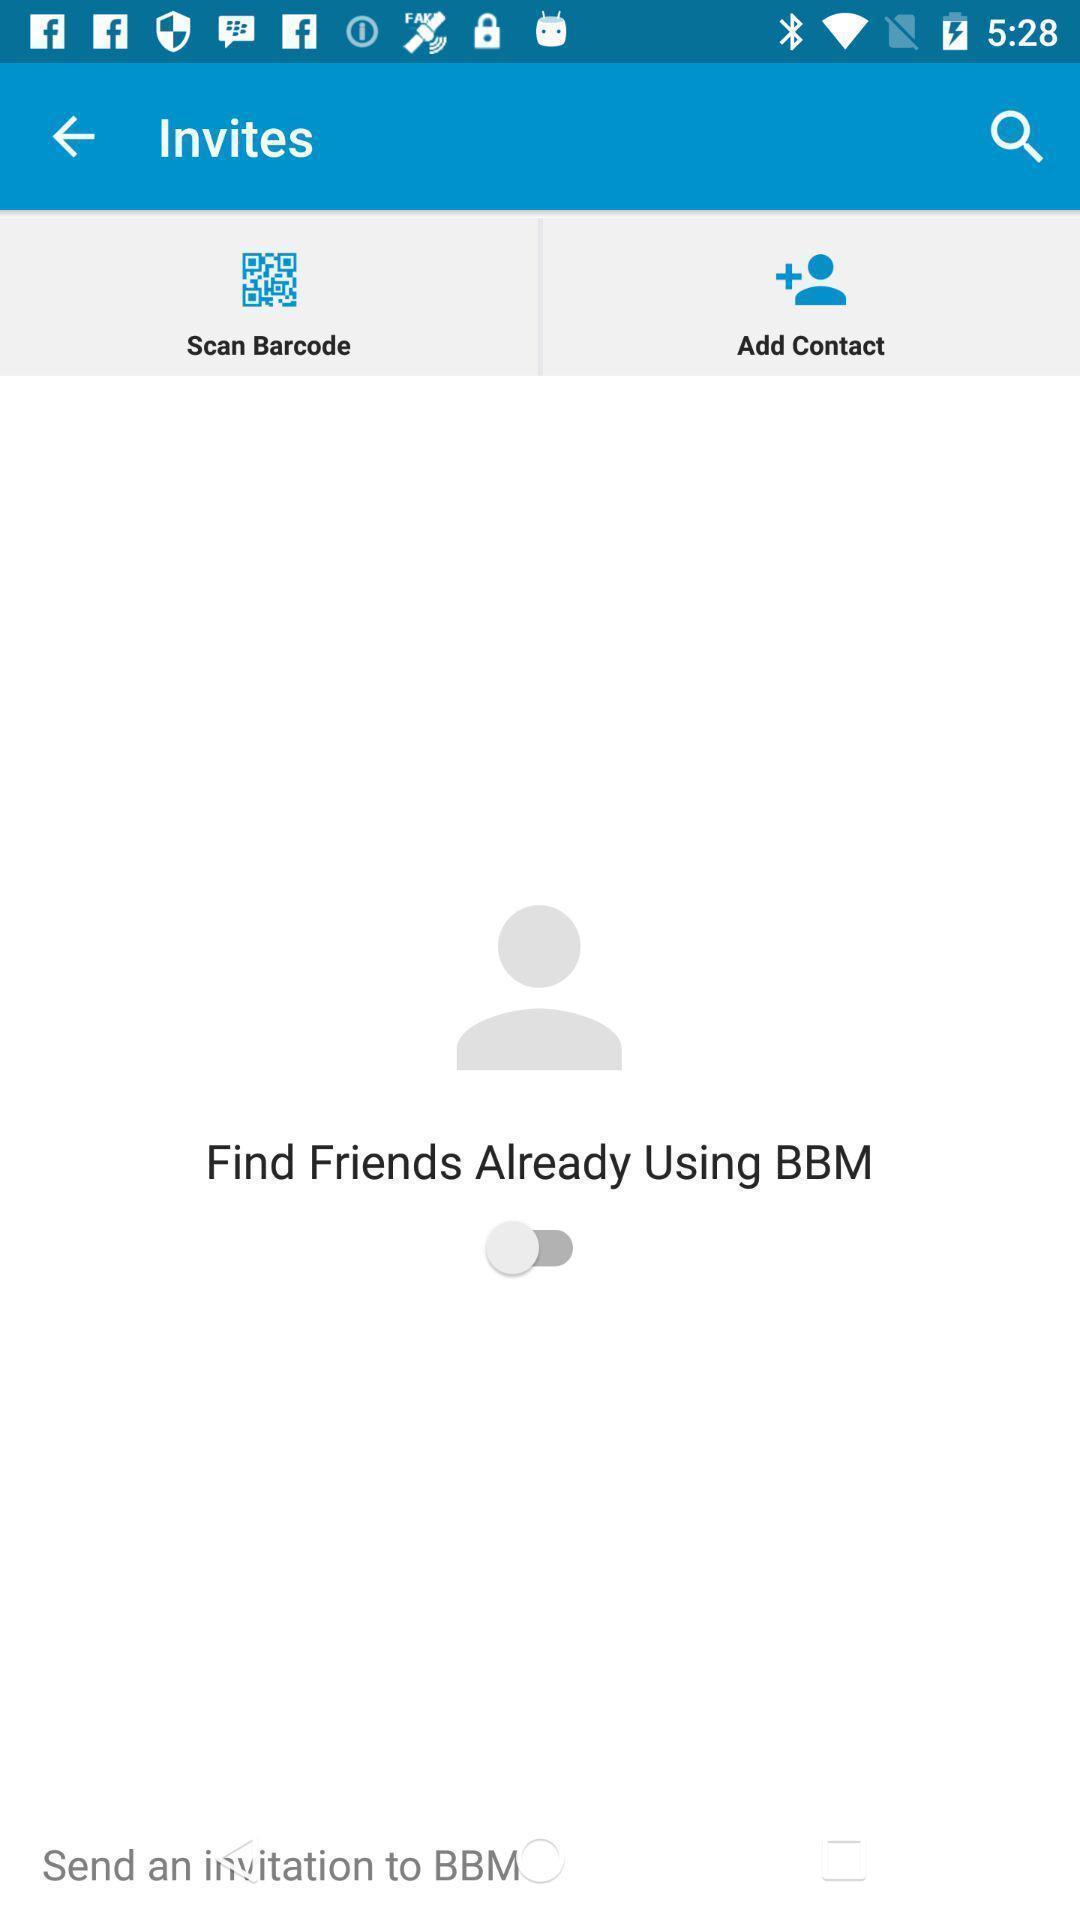Describe the key features of this screenshot. Page shows to find invites. 